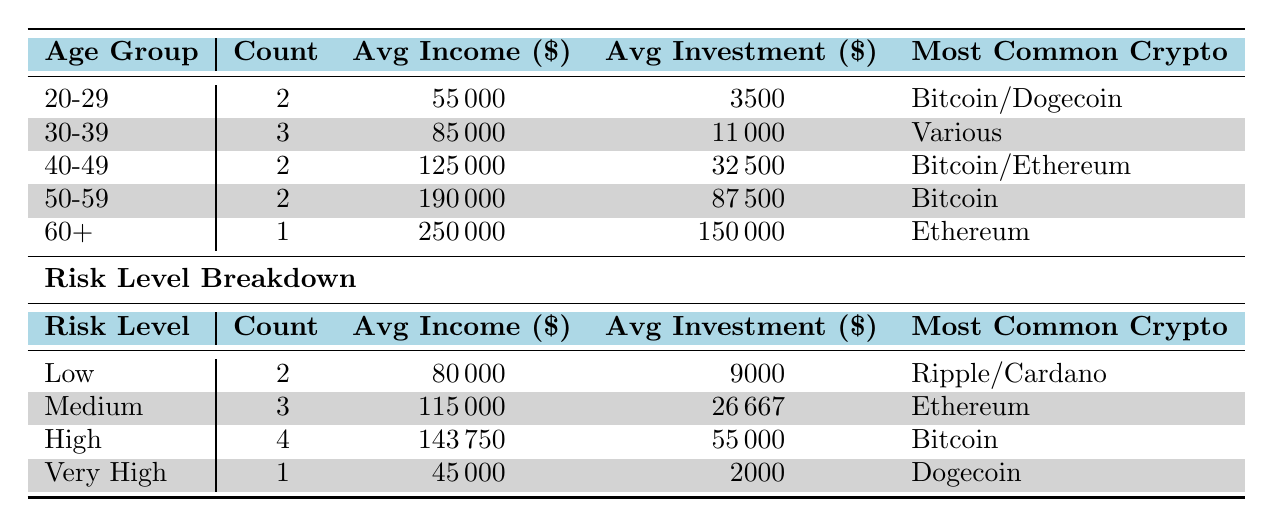What is the most common cryptocurrency among investors aged 20-29? The table shows that the age group 20-29 has two investors, with Bitcoin and Dogecoin both being noted as the most common cryptocurrencies for this group.
Answer: Bitcoin/Dogecoin How many investors have a risk level of 'High'? The table indicates that there are 4 investors classified under the 'High' risk level according to the relevant row.
Answer: 4 What is the average investment size for the age group of 50-59? The average investment size for the age group 50-59 can be found by referring to their respective row, which lists an average investment of 87500.
Answer: 87500 Is there any investor aged 60 or older who has a very high-risk level? According to the table, there is one investor in the 60+ age category, and they have a 'Medium' risk level. Thus, no investors aged 60 or older have a 'Very High' risk level.
Answer: No What is the total average income of investors in the 'Medium' risk level and those in the 'High' risk level combined? The average income for the 'Medium' risk level is 115000 and for the 'High' risk level is 143750. Adding them together gives 115000 + 143750 = 258750. To find the combined average, we divide this total by the number of groups (2): 258750 / 2 = 129375.
Answer: 129375 What is the most common cryptocurrency for investors who have an average investment size of 11000 or lower? Looking at the table, the 'Low' risk level has an average investment size of 9000 and lists Ripple/Cardano as the most common cryptocurrencies, which fits the criteria for average investments of 11000 or lower.
Answer: Ripple/Cardano How many investors have an income of 100000 or more? By reviewing the income column, we find that there are four investors with an income of 100000 or more: the investors aged 42, 52, 60, and 55.
Answer: 4 What is the average income of investors in the age group of 30-39? The average income listed for the 30-39 age group is 85000, which is directly provided in the table.
Answer: 85000 